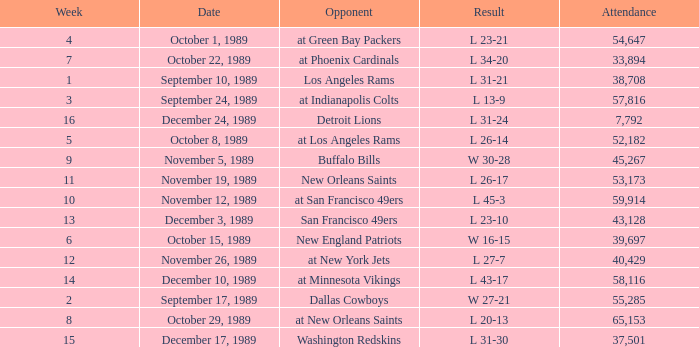For what week was the attendance 40,429? 12.0. 